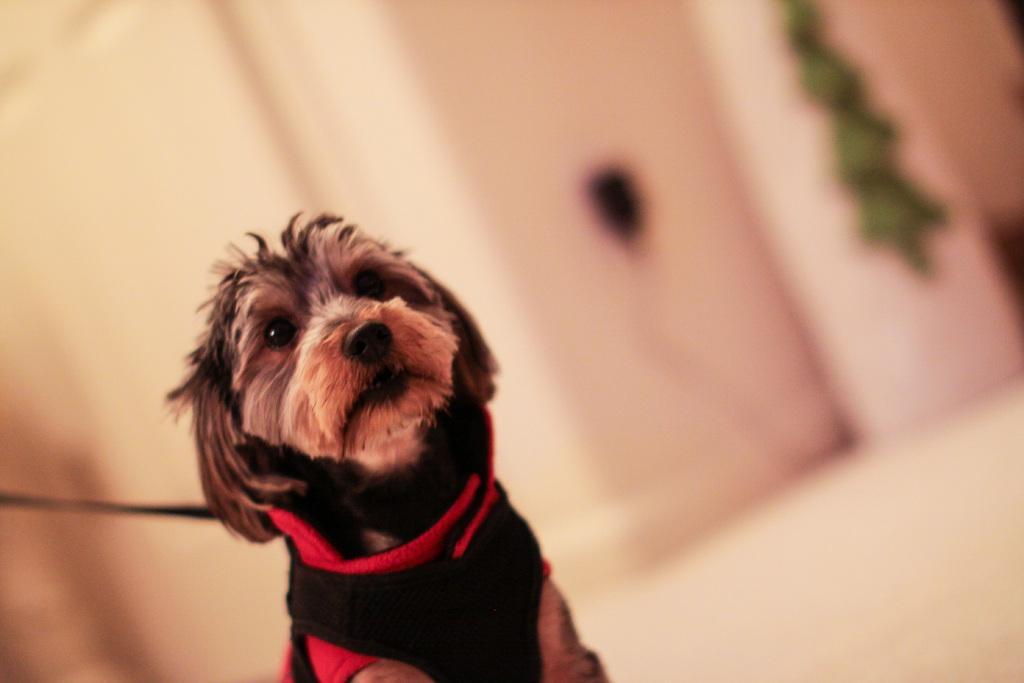Please provide a concise description of this image. In this picture we can see a dog. In the background of the image it is blurry. 